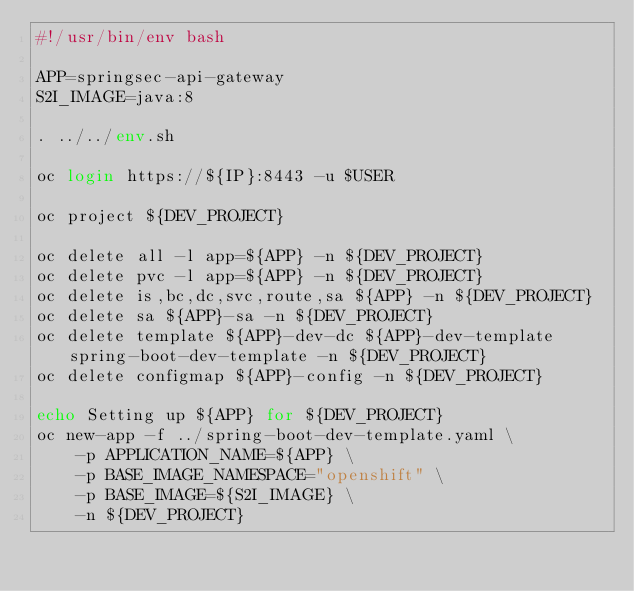<code> <loc_0><loc_0><loc_500><loc_500><_Bash_>#!/usr/bin/env bash

APP=springsec-api-gateway
S2I_IMAGE=java:8

. ../../env.sh

oc login https://${IP}:8443 -u $USER

oc project ${DEV_PROJECT}

oc delete all -l app=${APP} -n ${DEV_PROJECT}
oc delete pvc -l app=${APP} -n ${DEV_PROJECT}
oc delete is,bc,dc,svc,route,sa ${APP} -n ${DEV_PROJECT}
oc delete sa ${APP}-sa -n ${DEV_PROJECT}
oc delete template ${APP}-dev-dc ${APP}-dev-template spring-boot-dev-template -n ${DEV_PROJECT}
oc delete configmap ${APP}-config -n ${DEV_PROJECT}

echo Setting up ${APP} for ${DEV_PROJECT}
oc new-app -f ../spring-boot-dev-template.yaml \
    -p APPLICATION_NAME=${APP} \
    -p BASE_IMAGE_NAMESPACE="openshift" \
    -p BASE_IMAGE=${S2I_IMAGE} \
    -n ${DEV_PROJECT}

</code> 